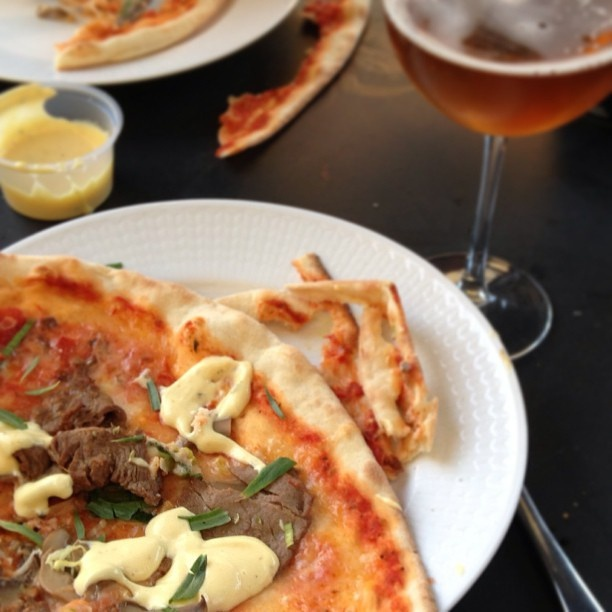Describe the objects in this image and their specific colors. I can see pizza in tan, khaki, brown, and red tones, dining table in tan, black, maroon, and gray tones, wine glass in tan, maroon, black, gray, and darkgray tones, pizza in tan and brown tones, and pizza in tan, brown, and maroon tones in this image. 